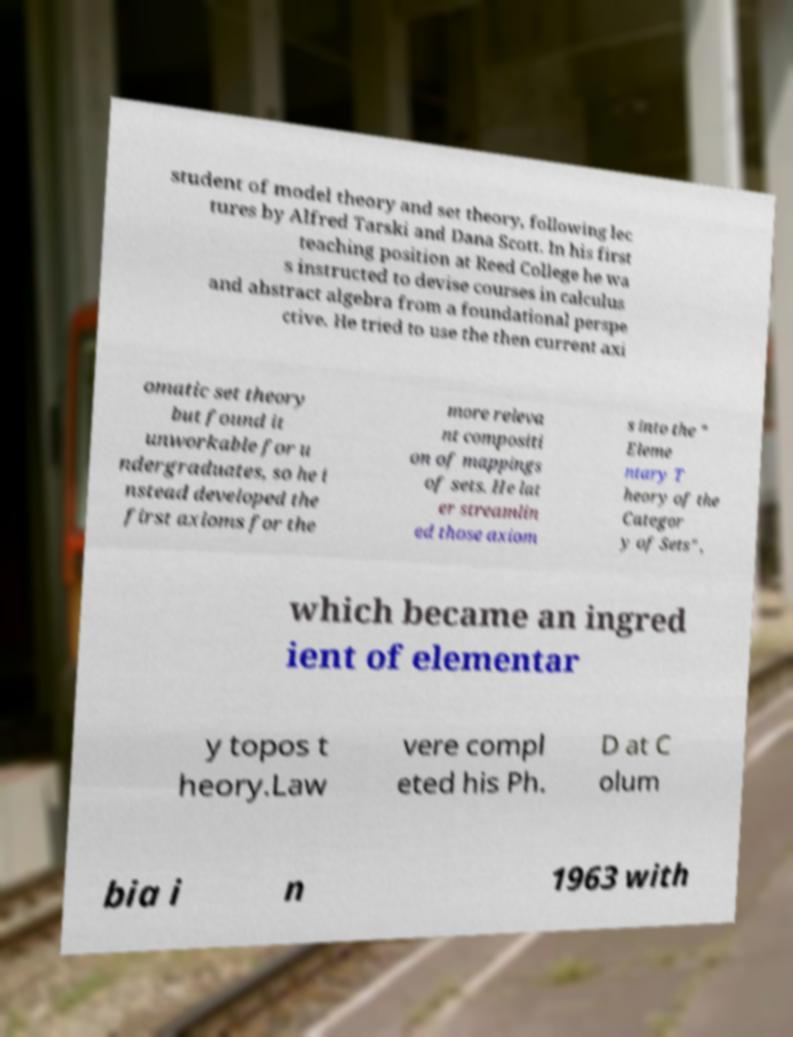Please read and relay the text visible in this image. What does it say? student of model theory and set theory, following lec tures by Alfred Tarski and Dana Scott. In his first teaching position at Reed College he wa s instructed to devise courses in calculus and abstract algebra from a foundational perspe ctive. He tried to use the then current axi omatic set theory but found it unworkable for u ndergraduates, so he i nstead developed the first axioms for the more releva nt compositi on of mappings of sets. He lat er streamlin ed those axiom s into the " Eleme ntary T heory of the Categor y of Sets" , which became an ingred ient of elementar y topos t heory.Law vere compl eted his Ph. D at C olum bia i n 1963 with 